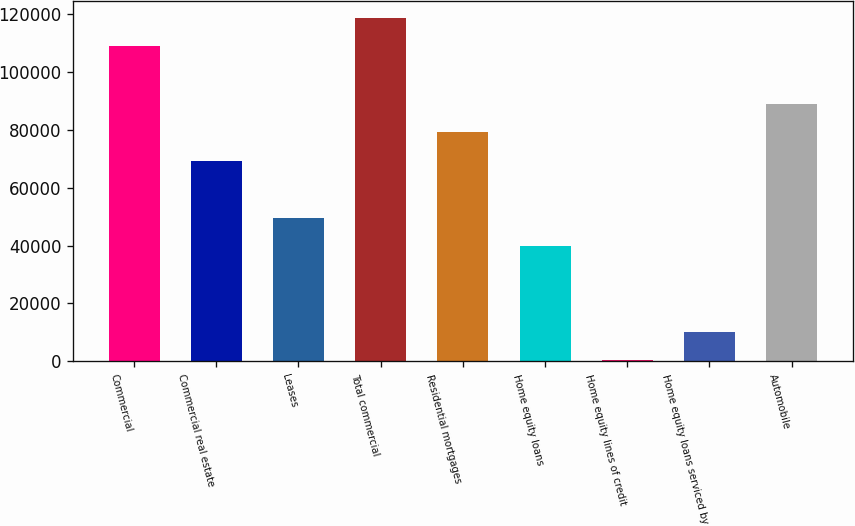Convert chart. <chart><loc_0><loc_0><loc_500><loc_500><bar_chart><fcel>Commercial<fcel>Commercial real estate<fcel>Leases<fcel>Total commercial<fcel>Residential mortgages<fcel>Home equity loans<fcel>Home equity lines of credit<fcel>Home equity loans serviced by<fcel>Automobile<nl><fcel>108907<fcel>69446.1<fcel>49715.5<fcel>118773<fcel>79311.4<fcel>39850.2<fcel>389<fcel>10254.3<fcel>89176.7<nl></chart> 